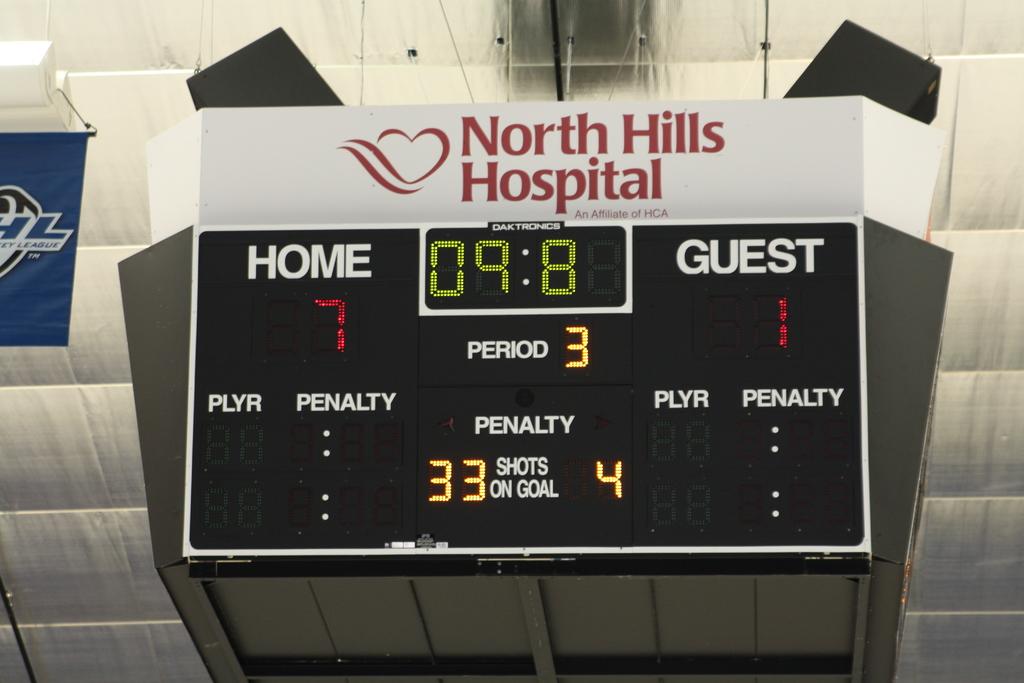What is the score?
Give a very brief answer. 7 to 1. What period is it?
Your answer should be very brief. 3. 